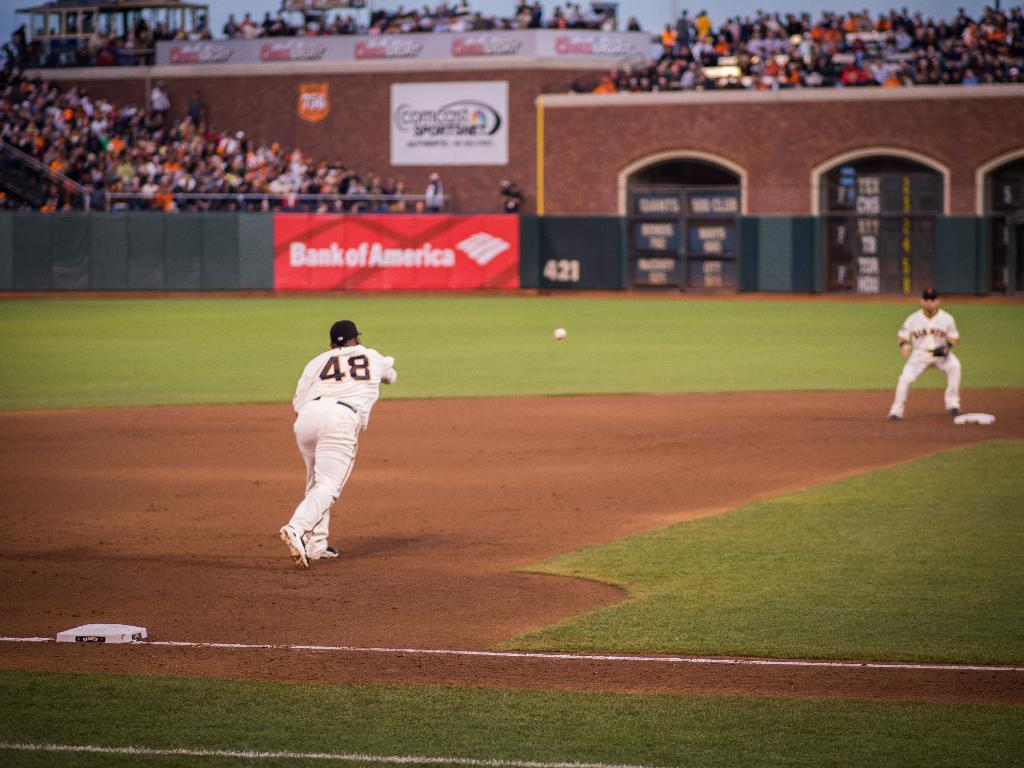<image>
Offer a succinct explanation of the picture presented. A baseball pitcher bearing the number 48 throws a ball towards a plate in a stdium bearing Bank of America sponsorship. 